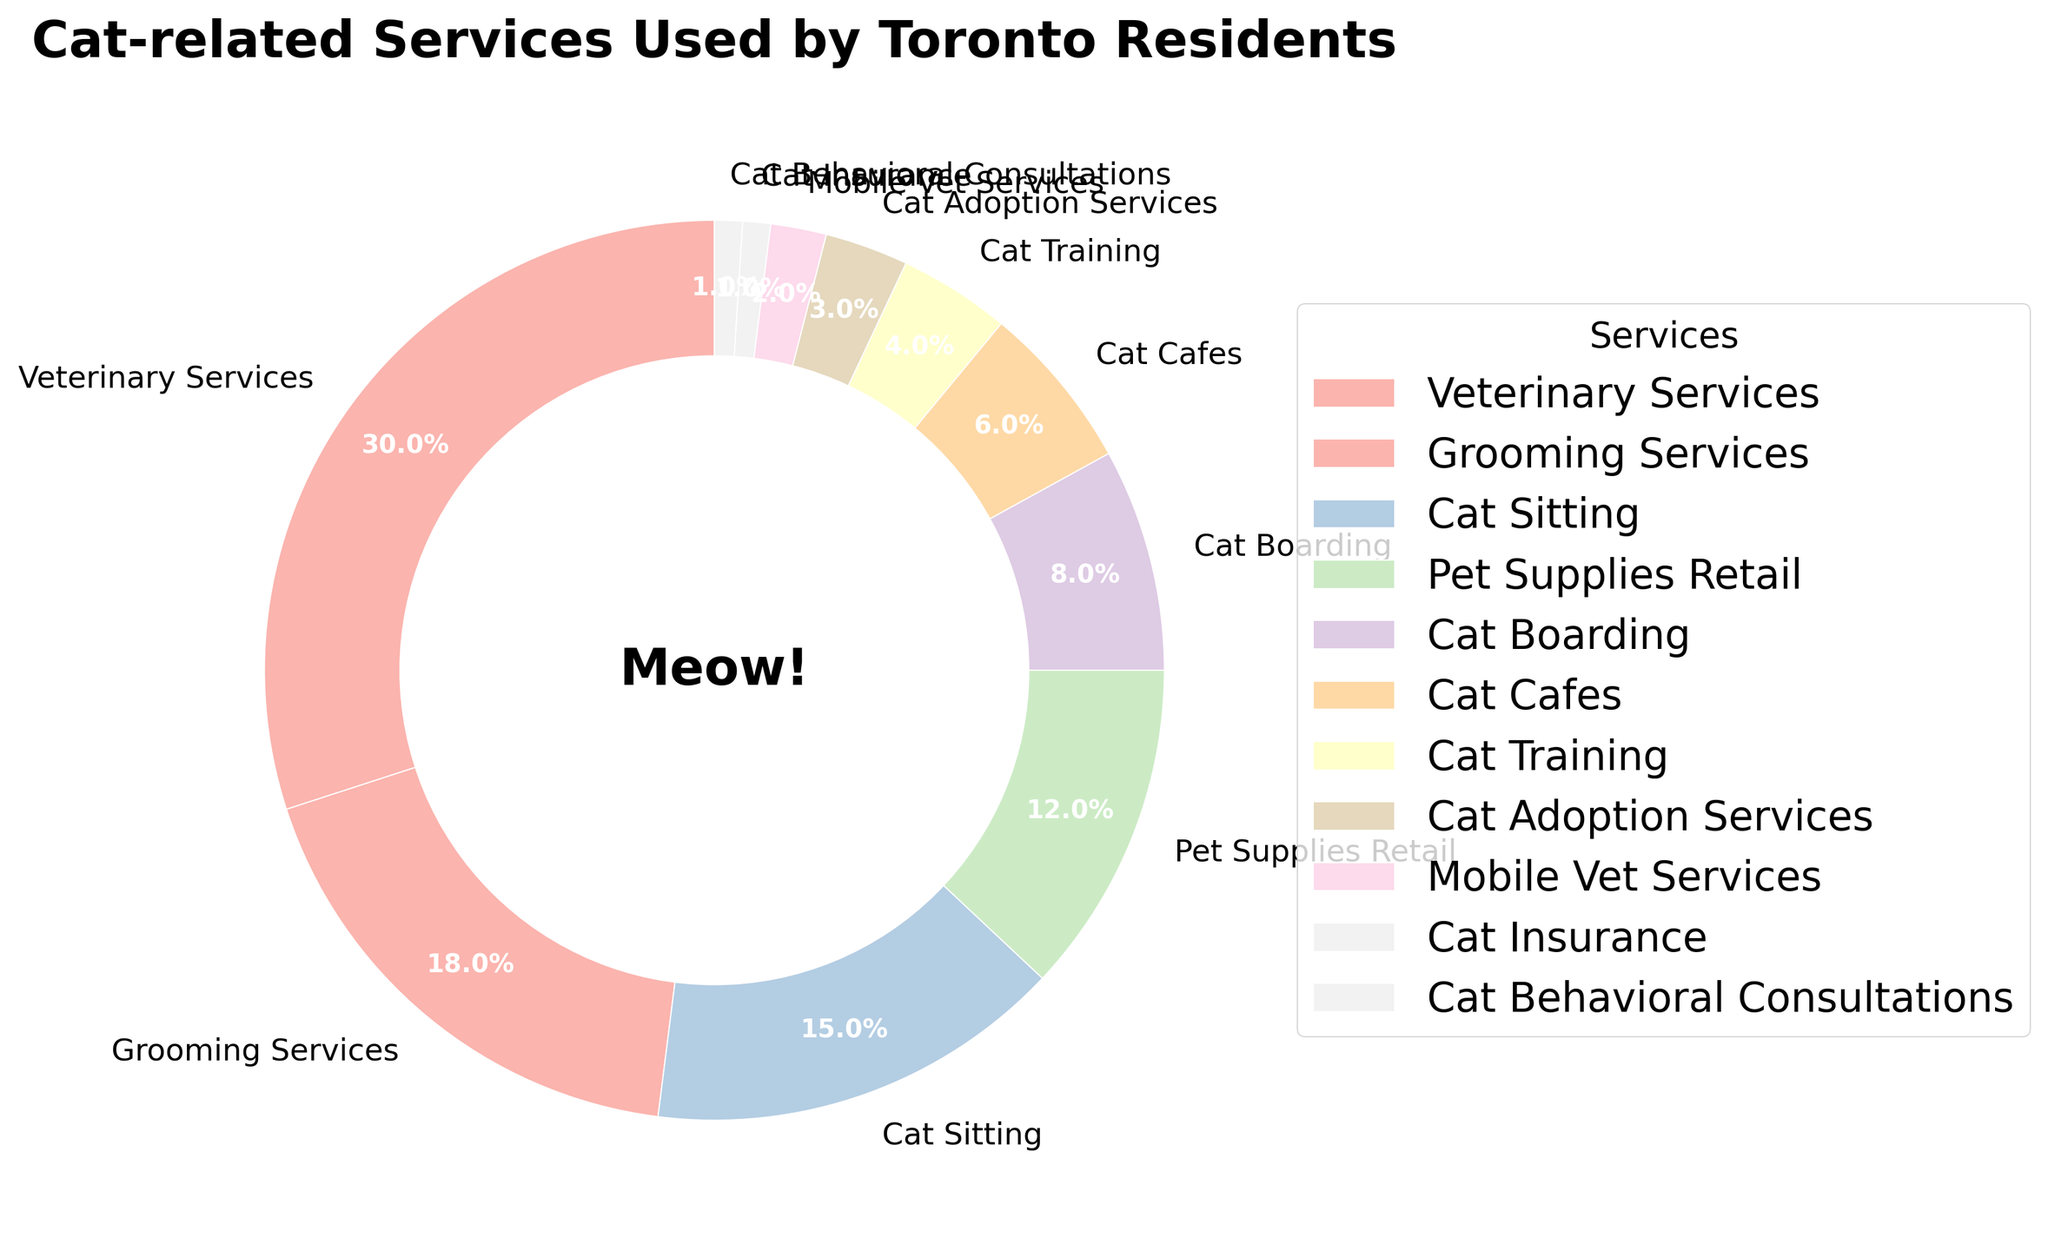Which category has the highest percentage of usage? To find out which category has the highest percentage, look at the figure and identify the largest wedge. Veterinary Services has the largest wedge with a 30% usage.
Answer: Veterinary Services Which two categories combined make up the least percentage of usage? To determine which two categories have the smallest combined percentage, look for the smallest wedges. Cat Insurance and Cat Behavioral Consultations each have 1%, summing to 2%.
Answer: Cat Insurance and Cat Behavioral Consultations How much more popular are Veterinary Services compared to Cat Training Services? To compare the percentages, subtract the smaller percentage from the larger one. Veterinary Services have 30%, and Cat Training Services have 4%, so the difference is 30% - 4% = 26%.
Answer: 26% What is the combined percentage of Grooming Services and Cat Sitting? Look at the percentages for Grooming Services and Cat Sitting, which are 18% and 15%, respectively. The combined percentage is 18% + 15% = 33%.
Answer: 33% Which categories make up exactly half of the pie chart? Half of the pie is 50%. Look for categories that sum to 50%. Veterinary Services (30%), Grooming Services (18%), and Cat Sitting (15%) come closest, exceeding slightly with 30% + 18% + 15% = 63%. Thus, 30% + 18% = 48% is closest while less than 50%.
Answer: Veterinary Services and Grooming Services Which categories have a lower percentage than Cat Cafes? Cat Cafes have a usage percentage of 6%. Look for categories with a smaller percentage: Cat Training (4%), Cat Adoption Services (3%), Mobile Vet Services (2%), Cat Insurance (1%), and Cat Behavioral Consultations (1%).
Answer: Cat Training, Cat Adoption Services, Mobile Vet Services, Cat Insurance, and Cat Behavioral Consultations What percentage of the pie chart is not Veterinary Services, Grooming Services, or Cat Sitting? To find this, calculate the sum of the percentages of Veterinary Services, Grooming Services, and Cat Sitting and subtract from 100%. Those percentages are 30%, 18%, and 15%, respectively. The sum is 30% + 18% + 15% = 63%. So, 100% - 63% = 37%.
Answer: 37% What is the difference in the percentage of usage between Pet Supplies Retail and Cat Boarding? To find the difference, subtract the smaller percentage from the larger one. Pet Supplies Retail has 12%, and Cat Boarding has 8%. The difference is 12% - 8% = 4%.
Answer: 4% Among Cat Adoption Services, Mobile Vet Services, and Cat Insurance, which category has the highest percentage? Compare the percentages for these three categories. Cat Adoption Services has 3%, Mobile Vet Services has 2%, and Cat Insurance has 1%. The highest percentage is 3% for Cat Adoption Services.
Answer: Cat Adoption Services How much more popular is Grooming Services than all categories with 2% or less combined? Grooming Services have 18%. Categories with 2% or less are Mobile Vet Services (2%), Cat Insurance (1%), and Cat Behavioral Consultations (1%), summing to 2% + 1% + 1% = 4%. The difference is 18% - 4% = 14%.
Answer: 14% 